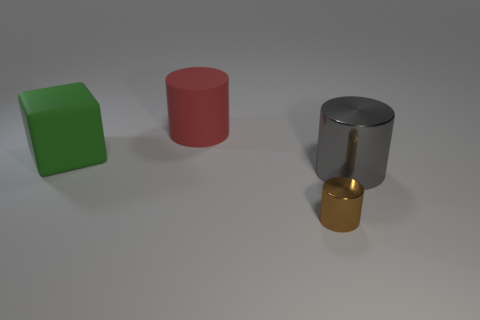Subtract all gray shiny cylinders. How many cylinders are left? 2 Add 2 big purple objects. How many objects exist? 6 Subtract all blocks. How many objects are left? 3 Subtract 2 cylinders. How many cylinders are left? 1 Subtract all green cylinders. Subtract all yellow balls. How many cylinders are left? 3 Subtract all large purple metal blocks. Subtract all tiny brown cylinders. How many objects are left? 3 Add 1 gray metal objects. How many gray metal objects are left? 2 Add 2 big matte cylinders. How many big matte cylinders exist? 3 Subtract 0 blue cylinders. How many objects are left? 4 